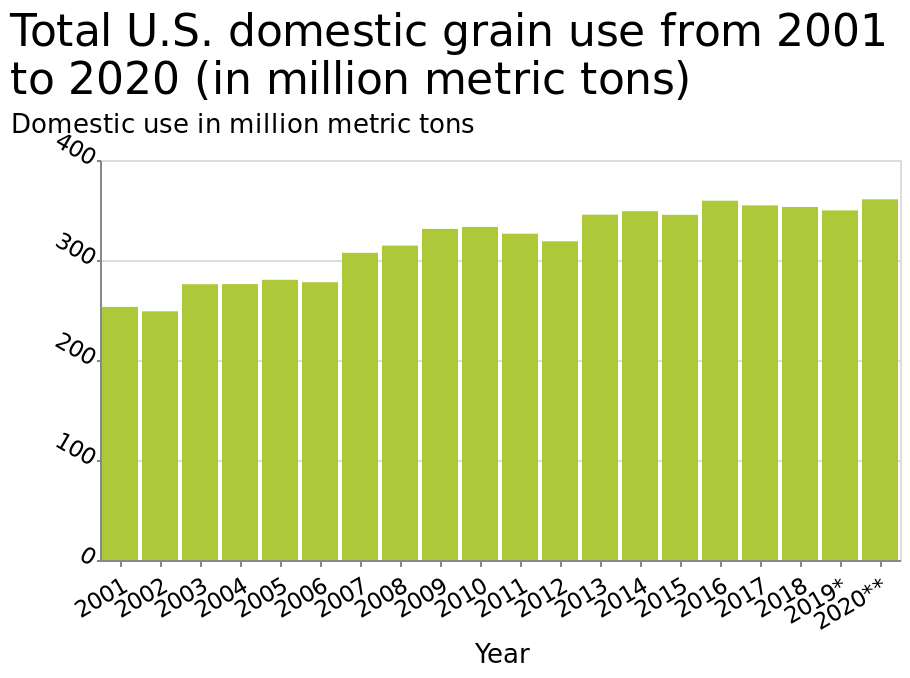<image>
Describe the following image in detail This bar chart is named Total U.S. domestic grain use from 2001 to 2020 (in million metric tons). There is a categorical scale starting at 2001 and ending at 2020** along the x-axis, labeled Year. The y-axis measures Domestic use in million metric tons. What does the x-axis of the graph represent?  The x-axis represents the years from 2001 to 2020. 